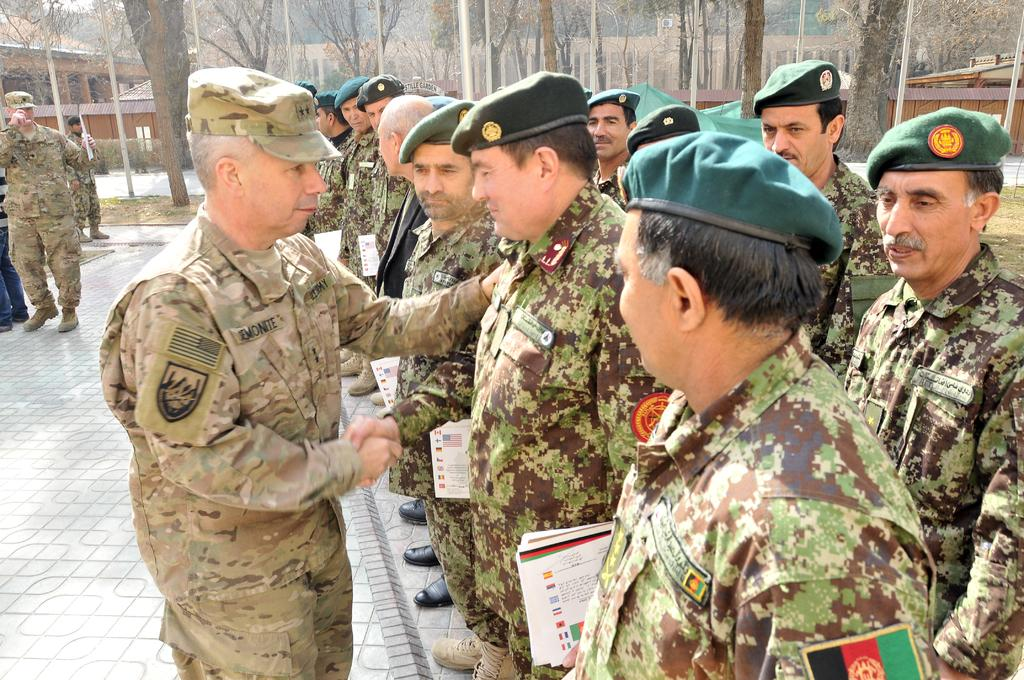What is the main subject of the image? There is a group of people in the image. What can be seen in the background of the image? There are poles, trees, and houses in the background of the image. What type of house is being smashed by the group of people in the image? There is no house being smashed in the image, nor is there any indication of the group of people engaging in such an activity. 